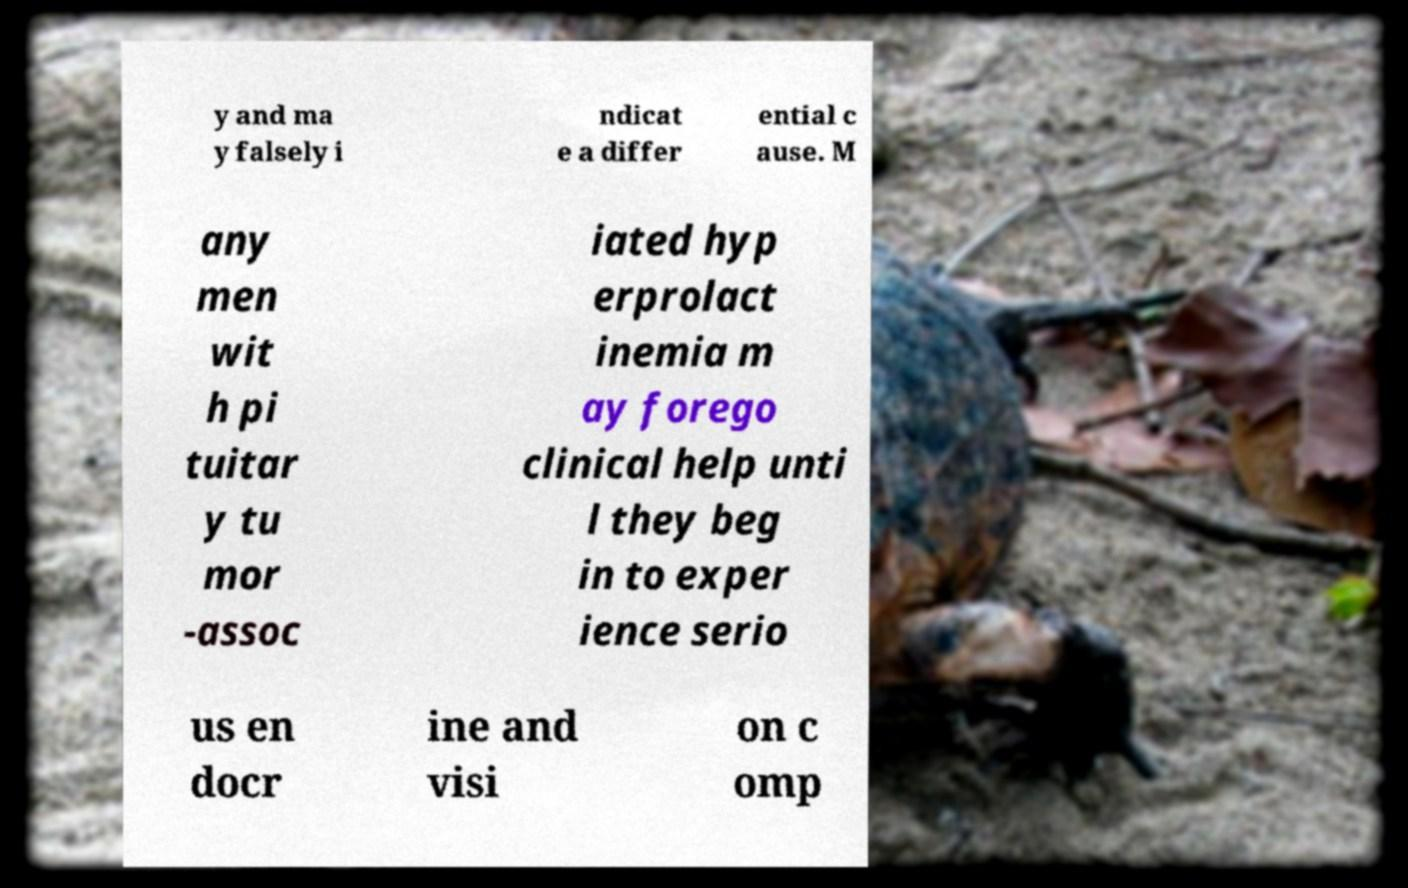What messages or text are displayed in this image? I need them in a readable, typed format. y and ma y falsely i ndicat e a differ ential c ause. M any men wit h pi tuitar y tu mor -assoc iated hyp erprolact inemia m ay forego clinical help unti l they beg in to exper ience serio us en docr ine and visi on c omp 